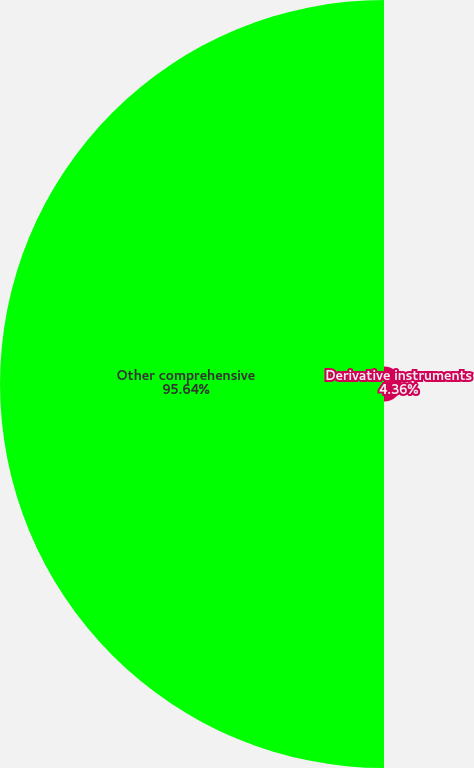<chart> <loc_0><loc_0><loc_500><loc_500><pie_chart><fcel>Derivative instruments<fcel>Other comprehensive<nl><fcel>4.36%<fcel>95.64%<nl></chart> 